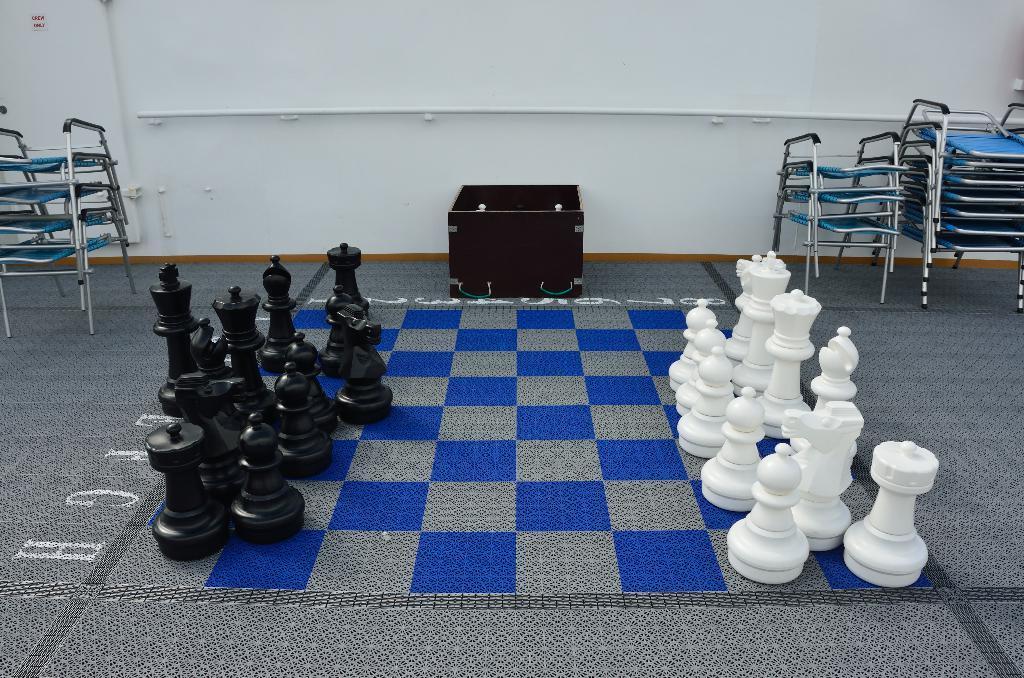Can you describe this image briefly? In this picture we can see a black and white chess pieces on a chess board, box and chairs on the floor, pipe and in the background we can see the wall. 